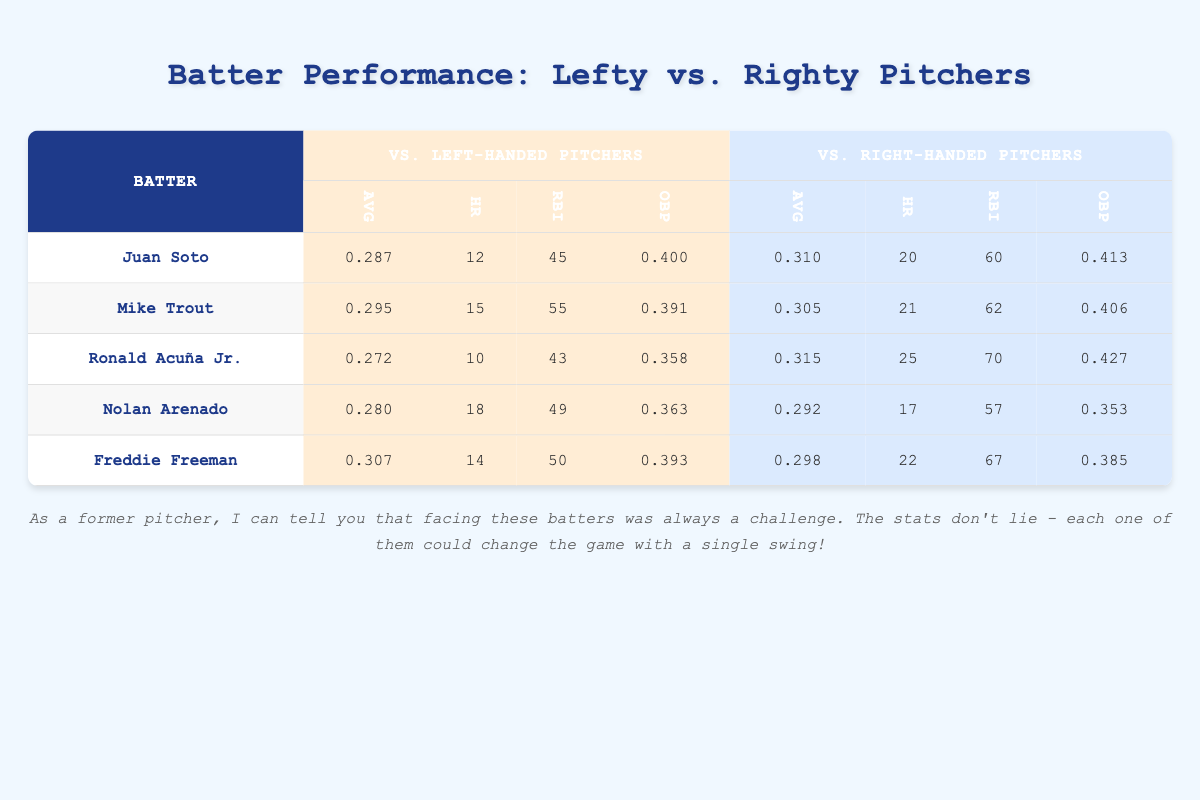What is Juan Soto's batting average against left-handed pitchers? The table shows that Juan Soto has a batting average (AVG) of 0.287 against left-handed pitchers, which is listed in the column labeled "AVG" under "vs. Left-handed Pitchers".
Answer: 0.287 How many home runs did Mike Trout hit against right-handed pitchers? The table indicates that Mike Trout hit 21 home runs (HR) against right-handed pitchers, as shown in the corresponding column.
Answer: 21 Which batter has the highest on-base percentage against right-handed pitchers? By examining the "OBP" column under "vs. Right-handed Pitchers", we see that Ronald Acuña Jr. has the highest on-base percentage at 0.427.
Answer: 0.427 What is the difference in home runs hit by Freddie Freeman against left-handed and right-handed pitchers? Freddie Freeman hit 14 home runs against left-handed pitchers and 22 against right-handed pitchers. To find the difference, we calculate 22 - 14 = 8.
Answer: 8 Is Nolan Arenado's average against left-handed pitchers higher than that against right-handed pitchers? The table shows Nolan Arenado's average against left-handed pitchers is 0.280, while against right-handed pitchers it is 0.292. Since 0.280 is less than 0.292, the statement is false.
Answer: No Which batter has the lowest run batted in (RBI) total against left-handed pitchers? In the RBI column for left-handed pitchers, we look for the lowest value. The table shows that Ronald Acuña Jr. has 43 RBIs against left-handers, which is the lowest among the listed batters.
Answer: 43 Summarize the total number of home runs hit by all listed batters against left-handed pitchers. To find the total, we sum the home runs from the "HR" column under "vs. Left-handed Pitchers": 12 + 15 + 10 + 18 + 14 = 69.
Answer: 69 What is the average Runners Batted In (RBI) for all batters against right-handed pitchers? We need to add the RBIs against right-handed pitchers: 60 (Soto) + 62 (Trout) + 70 (Acuña) + 57 (Arenado) + 67 (Freeman) = 316. Then, we divide by the number of batters (5): 316 / 5 = 63.2.
Answer: 63.2 Do all batters have better on-base percentages against right-handed pitchers compared to left-handed pitchers? We compare each batter's OBP for both types of pitchers. The table shows that only Acuña and Freeman have higher OBPs against right-handed pitchers, while Soto, Trout, and Arenado do not. Therefore, the statement is false.
Answer: No 